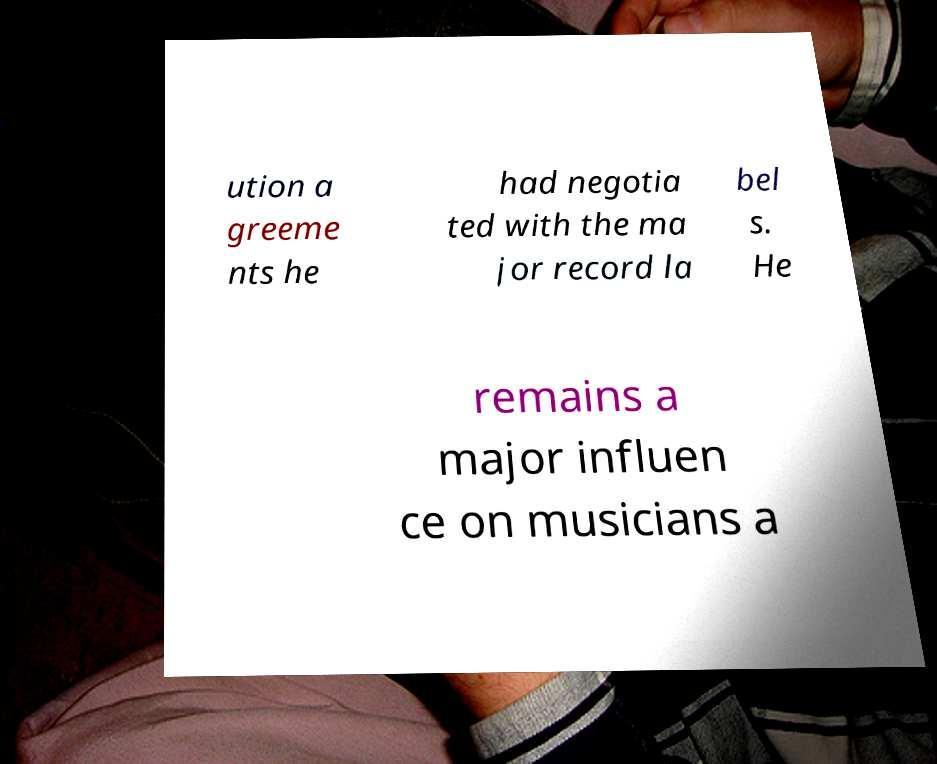Could you extract and type out the text from this image? ution a greeme nts he had negotia ted with the ma jor record la bel s. He remains a major influen ce on musicians a 